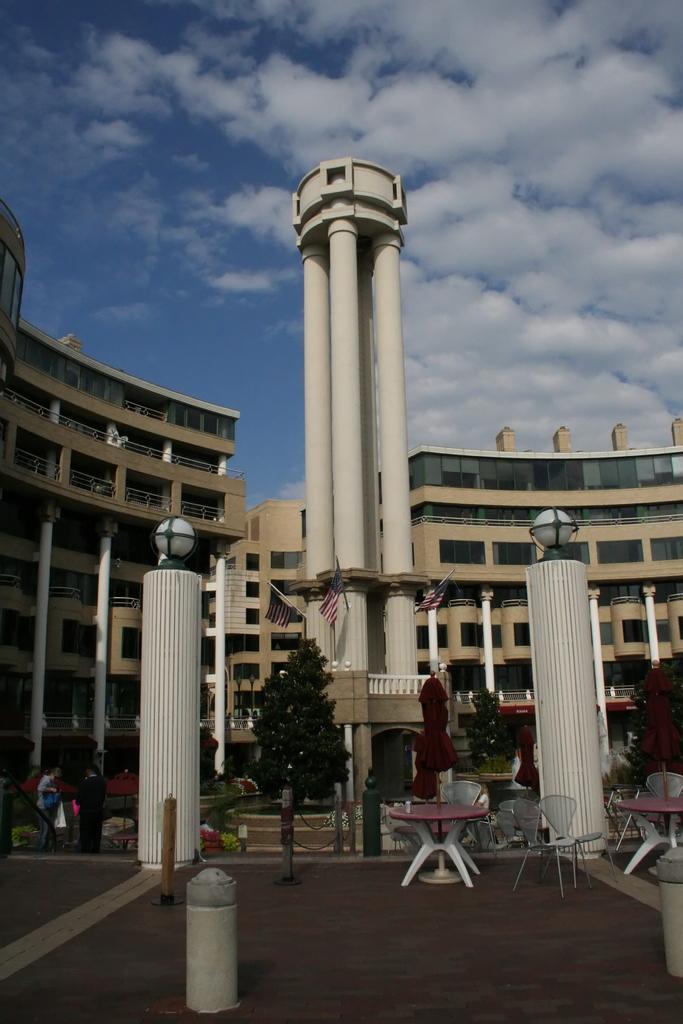Please provide a concise description of this image. This image consists of a building. In the front, there are tables and chairs. At the bottom, there is a road. At the top, there are clouds in the sky. In the middle, we can see the pillars along with the lights. 